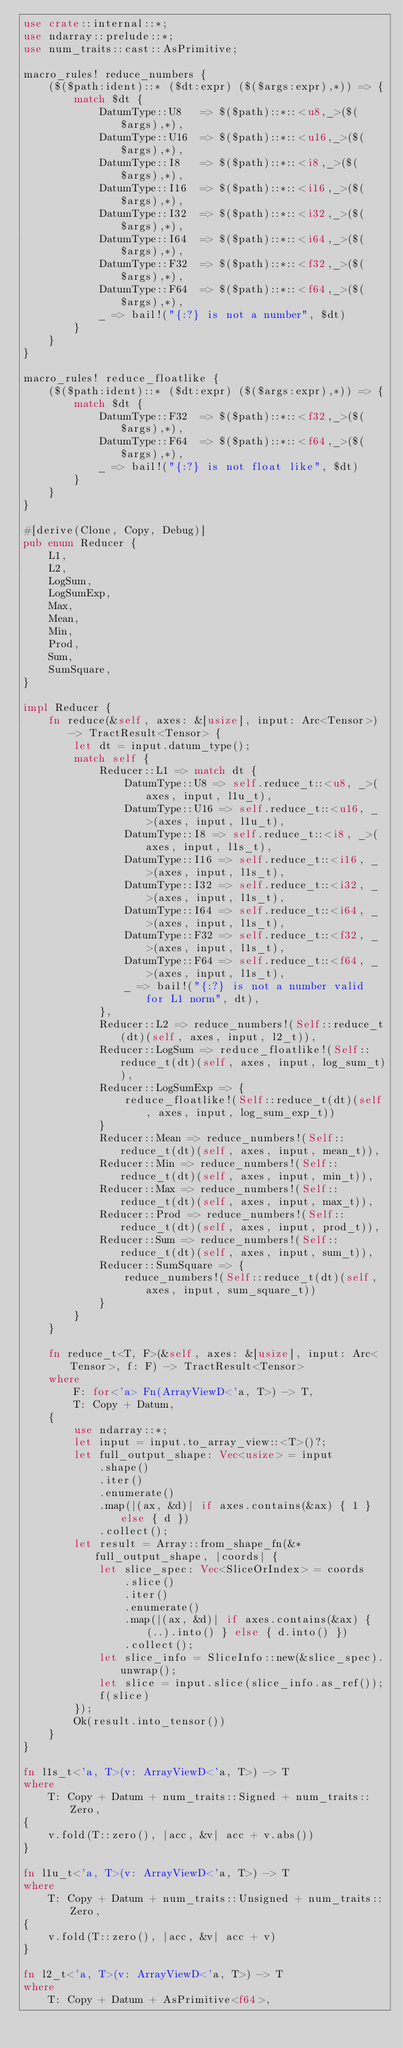<code> <loc_0><loc_0><loc_500><loc_500><_Rust_>use crate::internal::*;
use ndarray::prelude::*;
use num_traits::cast::AsPrimitive;

macro_rules! reduce_numbers {
    ($($path:ident)::* ($dt:expr) ($($args:expr),*)) => {
        match $dt {
            DatumType::U8   => $($path)::*::<u8,_>($($args),*),
            DatumType::U16  => $($path)::*::<u16,_>($($args),*),
            DatumType::I8   => $($path)::*::<i8,_>($($args),*),
            DatumType::I16  => $($path)::*::<i16,_>($($args),*),
            DatumType::I32  => $($path)::*::<i32,_>($($args),*),
            DatumType::I64  => $($path)::*::<i64,_>($($args),*),
            DatumType::F32  => $($path)::*::<f32,_>($($args),*),
            DatumType::F64  => $($path)::*::<f64,_>($($args),*),
            _ => bail!("{:?} is not a number", $dt)
        }
    }
}

macro_rules! reduce_floatlike {
    ($($path:ident)::* ($dt:expr) ($($args:expr),*)) => {
        match $dt {
            DatumType::F32  => $($path)::*::<f32,_>($($args),*),
            DatumType::F64  => $($path)::*::<f64,_>($($args),*),
            _ => bail!("{:?} is not float like", $dt)
        }
    }
}

#[derive(Clone, Copy, Debug)]
pub enum Reducer {
    L1,
    L2,
    LogSum,
    LogSumExp,
    Max,
    Mean,
    Min,
    Prod,
    Sum,
    SumSquare,
}

impl Reducer {
    fn reduce(&self, axes: &[usize], input: Arc<Tensor>) -> TractResult<Tensor> {
        let dt = input.datum_type();
        match self {
            Reducer::L1 => match dt {
                DatumType::U8 => self.reduce_t::<u8, _>(axes, input, l1u_t),
                DatumType::U16 => self.reduce_t::<u16, _>(axes, input, l1u_t),
                DatumType::I8 => self.reduce_t::<i8, _>(axes, input, l1s_t),
                DatumType::I16 => self.reduce_t::<i16, _>(axes, input, l1s_t),
                DatumType::I32 => self.reduce_t::<i32, _>(axes, input, l1s_t),
                DatumType::I64 => self.reduce_t::<i64, _>(axes, input, l1s_t),
                DatumType::F32 => self.reduce_t::<f32, _>(axes, input, l1s_t),
                DatumType::F64 => self.reduce_t::<f64, _>(axes, input, l1s_t),
                _ => bail!("{:?} is not a number valid for L1 norm", dt),
            },
            Reducer::L2 => reduce_numbers!(Self::reduce_t(dt)(self, axes, input, l2_t)),
            Reducer::LogSum => reduce_floatlike!(Self::reduce_t(dt)(self, axes, input, log_sum_t)),
            Reducer::LogSumExp => {
                reduce_floatlike!(Self::reduce_t(dt)(self, axes, input, log_sum_exp_t))
            }
            Reducer::Mean => reduce_numbers!(Self::reduce_t(dt)(self, axes, input, mean_t)),
            Reducer::Min => reduce_numbers!(Self::reduce_t(dt)(self, axes, input, min_t)),
            Reducer::Max => reduce_numbers!(Self::reduce_t(dt)(self, axes, input, max_t)),
            Reducer::Prod => reduce_numbers!(Self::reduce_t(dt)(self, axes, input, prod_t)),
            Reducer::Sum => reduce_numbers!(Self::reduce_t(dt)(self, axes, input, sum_t)),
            Reducer::SumSquare => {
                reduce_numbers!(Self::reduce_t(dt)(self, axes, input, sum_square_t))
            }
        }
    }

    fn reduce_t<T, F>(&self, axes: &[usize], input: Arc<Tensor>, f: F) -> TractResult<Tensor>
    where
        F: for<'a> Fn(ArrayViewD<'a, T>) -> T,
        T: Copy + Datum,
    {
        use ndarray::*;
        let input = input.to_array_view::<T>()?;
        let full_output_shape: Vec<usize> = input
            .shape()
            .iter()
            .enumerate()
            .map(|(ax, &d)| if axes.contains(&ax) { 1 } else { d })
            .collect();
        let result = Array::from_shape_fn(&*full_output_shape, |coords| {
            let slice_spec: Vec<SliceOrIndex> = coords
                .slice()
                .iter()
                .enumerate()
                .map(|(ax, &d)| if axes.contains(&ax) { (..).into() } else { d.into() })
                .collect();
            let slice_info = SliceInfo::new(&slice_spec).unwrap();
            let slice = input.slice(slice_info.as_ref());
            f(slice)
        });
        Ok(result.into_tensor())
    }
}

fn l1s_t<'a, T>(v: ArrayViewD<'a, T>) -> T
where
    T: Copy + Datum + num_traits::Signed + num_traits::Zero,
{
    v.fold(T::zero(), |acc, &v| acc + v.abs())
}

fn l1u_t<'a, T>(v: ArrayViewD<'a, T>) -> T
where
    T: Copy + Datum + num_traits::Unsigned + num_traits::Zero,
{
    v.fold(T::zero(), |acc, &v| acc + v)
}

fn l2_t<'a, T>(v: ArrayViewD<'a, T>) -> T
where
    T: Copy + Datum + AsPrimitive<f64>,</code> 